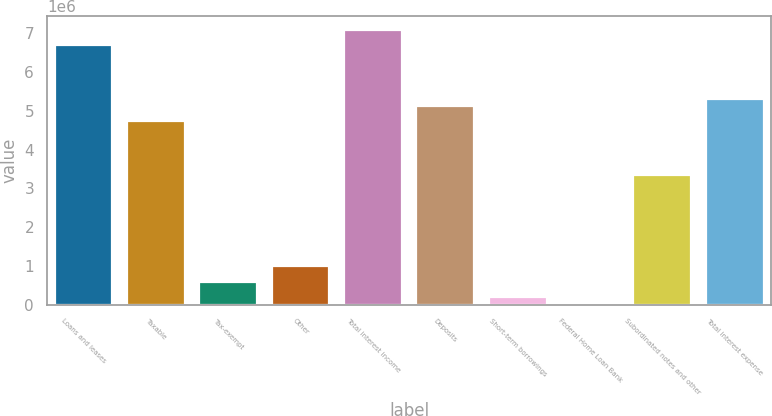Convert chart. <chart><loc_0><loc_0><loc_500><loc_500><bar_chart><fcel>Loans and leases<fcel>Taxable<fcel>Tax-exempt<fcel>Other<fcel>Total interest income<fcel>Deposits<fcel>Short-term borrowings<fcel>Federal Home Loan Bank<fcel>Subordinated notes and other<fcel>Total interest expense<nl><fcel>6.69679e+06<fcel>4.72739e+06<fcel>591645<fcel>985525<fcel>7.09067e+06<fcel>5.12127e+06<fcel>197764<fcel>824<fcel>3.34881e+06<fcel>5.31821e+06<nl></chart> 